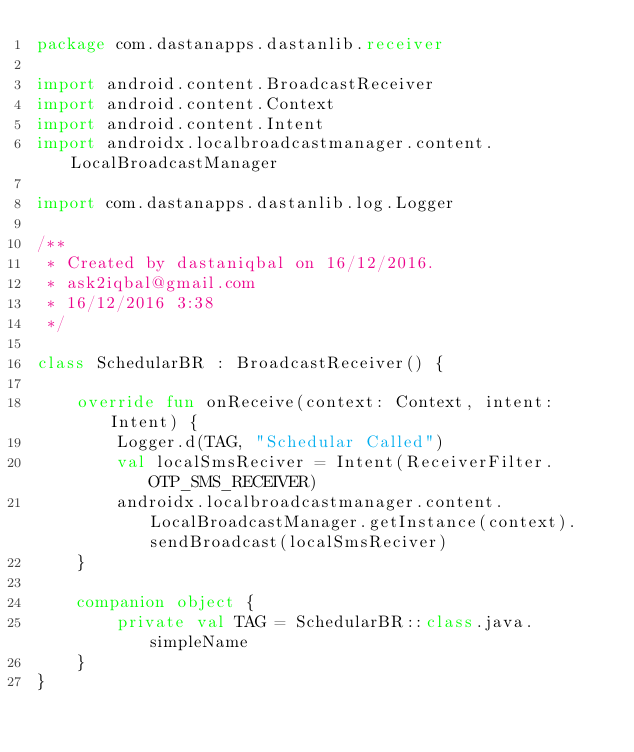Convert code to text. <code><loc_0><loc_0><loc_500><loc_500><_Kotlin_>package com.dastanapps.dastanlib.receiver

import android.content.BroadcastReceiver
import android.content.Context
import android.content.Intent
import androidx.localbroadcastmanager.content.LocalBroadcastManager

import com.dastanapps.dastanlib.log.Logger

/**
 * Created by dastaniqbal on 16/12/2016.
 * ask2iqbal@gmail.com
 * 16/12/2016 3:38
 */

class SchedularBR : BroadcastReceiver() {

    override fun onReceive(context: Context, intent: Intent) {
        Logger.d(TAG, "Schedular Called")
        val localSmsReciver = Intent(ReceiverFilter.OTP_SMS_RECEIVER)
        androidx.localbroadcastmanager.content.LocalBroadcastManager.getInstance(context).sendBroadcast(localSmsReciver)
    }

    companion object {
        private val TAG = SchedularBR::class.java.simpleName
    }
}
</code> 